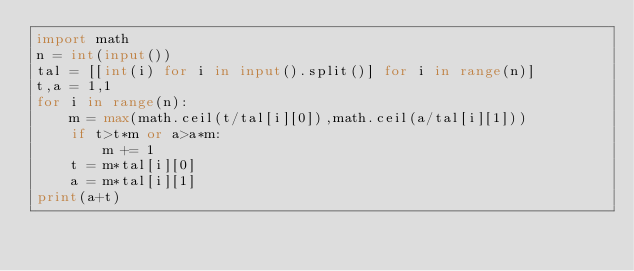<code> <loc_0><loc_0><loc_500><loc_500><_Python_>import math
n = int(input())
tal = [[int(i) for i in input().split()] for i in range(n)]
t,a = 1,1 
for i in range(n):
    m = max(math.ceil(t/tal[i][0]),math.ceil(a/tal[i][1]))
    if t>t*m or a>a*m:
        m += 1
    t = m*tal[i][0]
    a = m*tal[i][1]
print(a+t)
</code> 